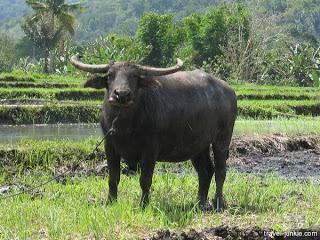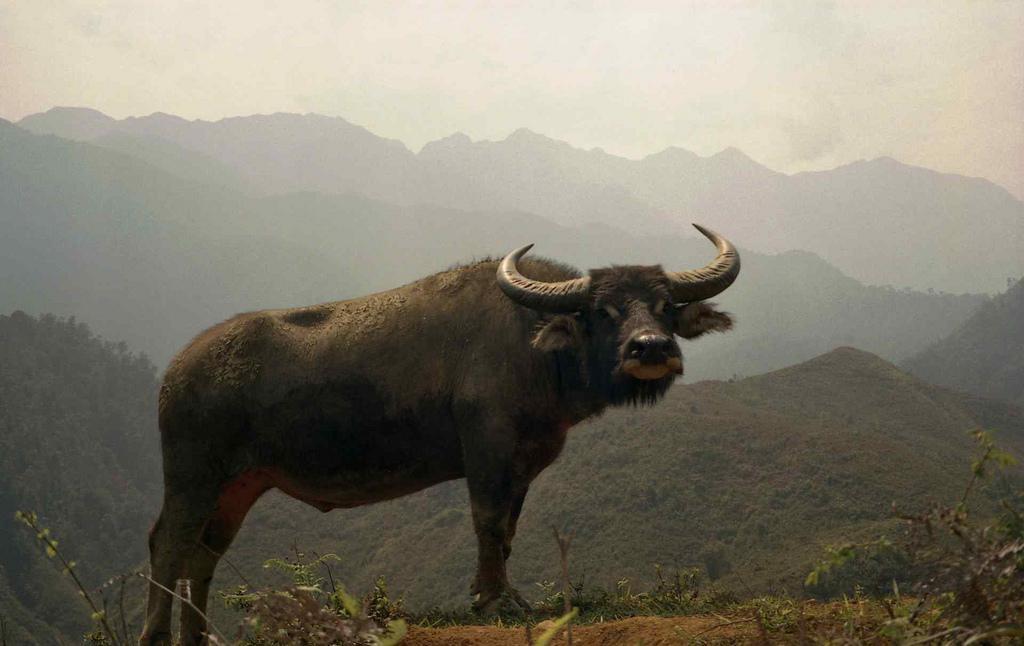The first image is the image on the left, the second image is the image on the right. Analyze the images presented: Is the assertion "The combined images include multiple people wearing hats, multiple water buffalos, and at least one person wearing a hat while on top of a water buffalo." valid? Answer yes or no. No. The first image is the image on the left, the second image is the image on the right. Assess this claim about the two images: "There is exactly one person sitting on an animal.". Correct or not? Answer yes or no. No. 